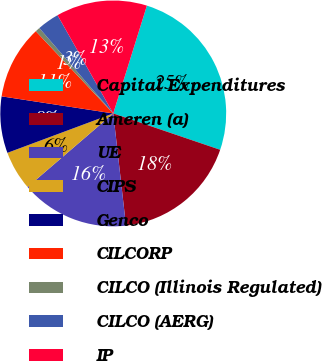Convert chart. <chart><loc_0><loc_0><loc_500><loc_500><pie_chart><fcel>Capital Expenditures<fcel>Ameren (a)<fcel>UE<fcel>CIPS<fcel>Genco<fcel>CILCORP<fcel>CILCO (Illinois Regulated)<fcel>CILCO (AERG)<fcel>IP<nl><fcel>25.4%<fcel>17.98%<fcel>15.51%<fcel>5.62%<fcel>8.09%<fcel>10.56%<fcel>0.67%<fcel>3.14%<fcel>13.03%<nl></chart> 